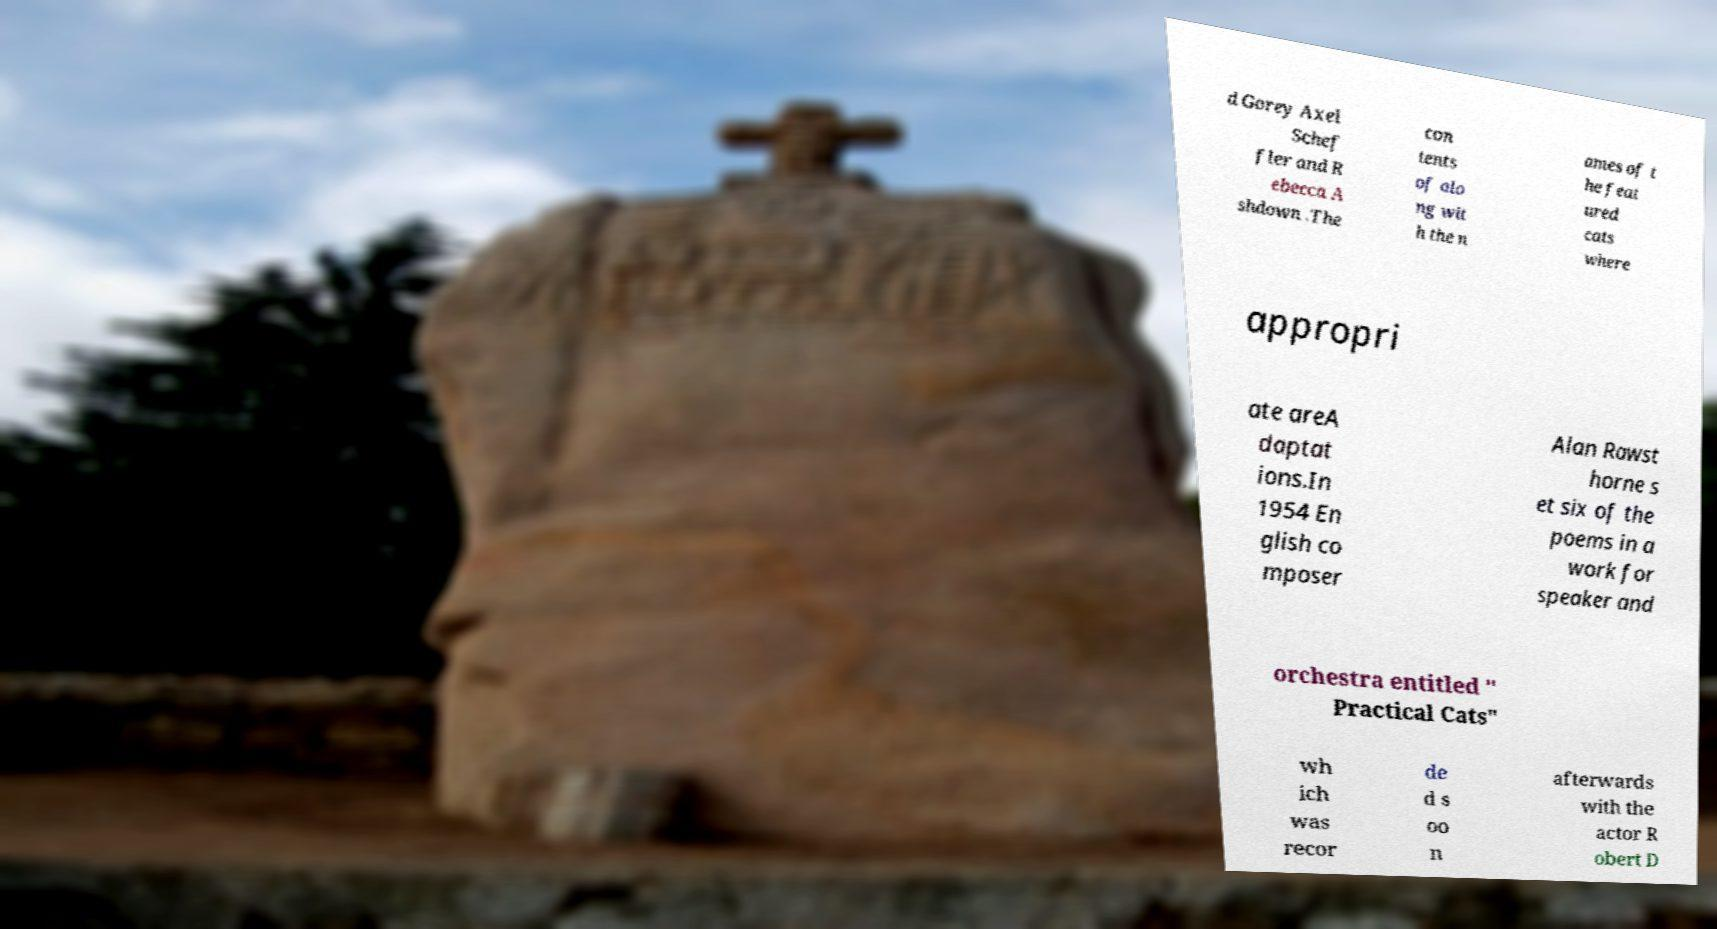For documentation purposes, I need the text within this image transcribed. Could you provide that? d Gorey Axel Schef fler and R ebecca A shdown .The con tents of alo ng wit h the n ames of t he feat ured cats where appropri ate areA daptat ions.In 1954 En glish co mposer Alan Rawst horne s et six of the poems in a work for speaker and orchestra entitled " Practical Cats" wh ich was recor de d s oo n afterwards with the actor R obert D 